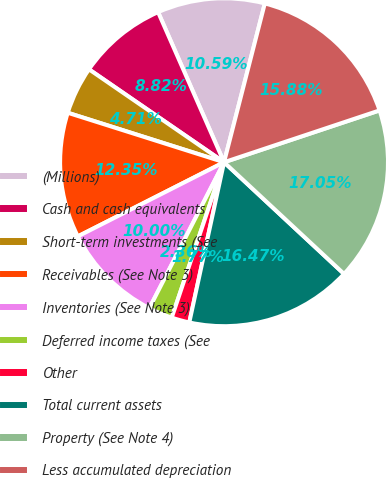Convert chart. <chart><loc_0><loc_0><loc_500><loc_500><pie_chart><fcel>(Millions)<fcel>Cash and cash equivalents<fcel>Short-term investments (See<fcel>Receivables (See Note 3)<fcel>Inventories (See Note 3)<fcel>Deferred income taxes (See<fcel>Other<fcel>Total current assets<fcel>Property (See Note 4)<fcel>Less accumulated depreciation<nl><fcel>10.59%<fcel>8.82%<fcel>4.71%<fcel>12.35%<fcel>10.0%<fcel>2.36%<fcel>1.77%<fcel>16.47%<fcel>17.05%<fcel>15.88%<nl></chart> 